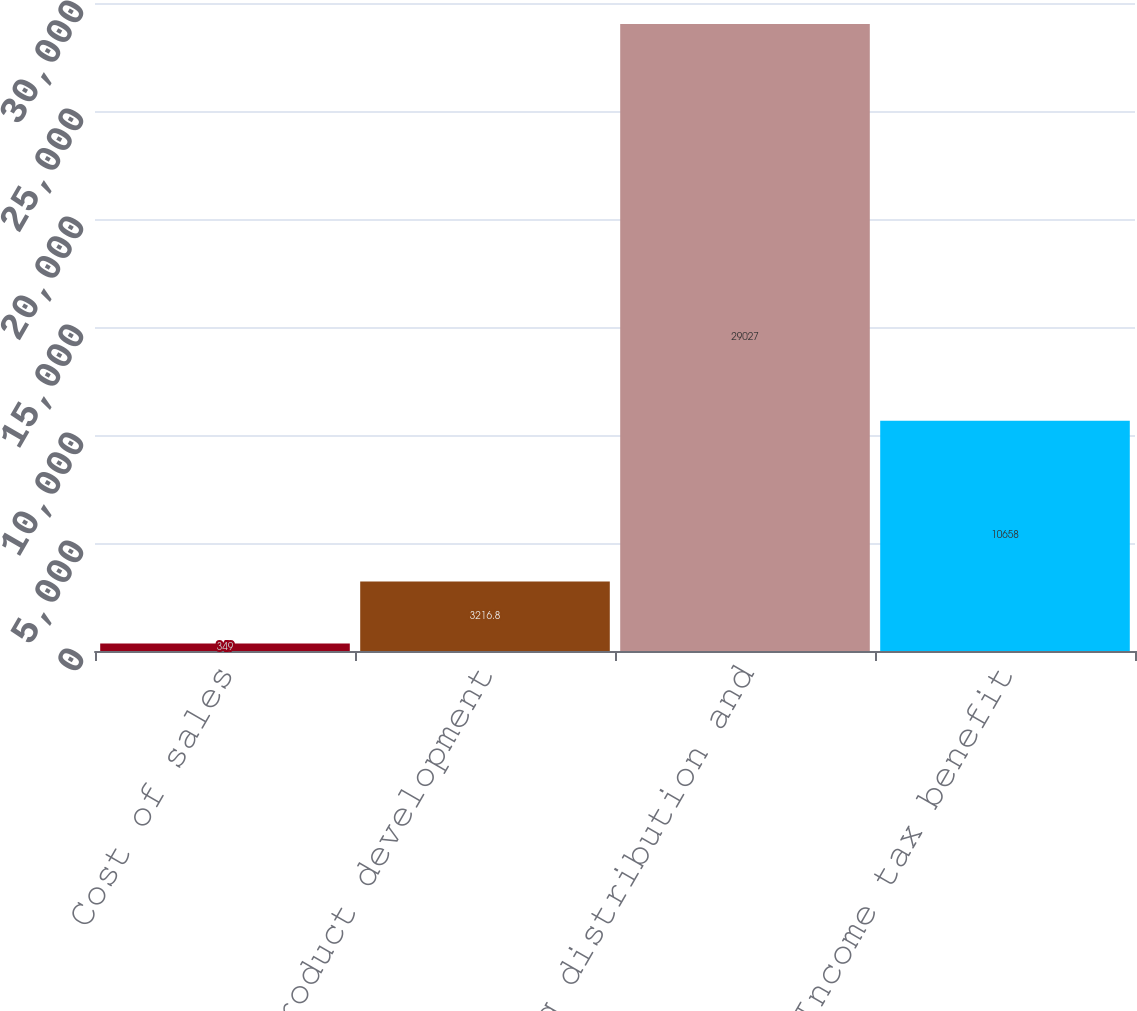<chart> <loc_0><loc_0><loc_500><loc_500><bar_chart><fcel>Cost of sales<fcel>Product development<fcel>Selling distribution and<fcel>Income tax benefit<nl><fcel>349<fcel>3216.8<fcel>29027<fcel>10658<nl></chart> 